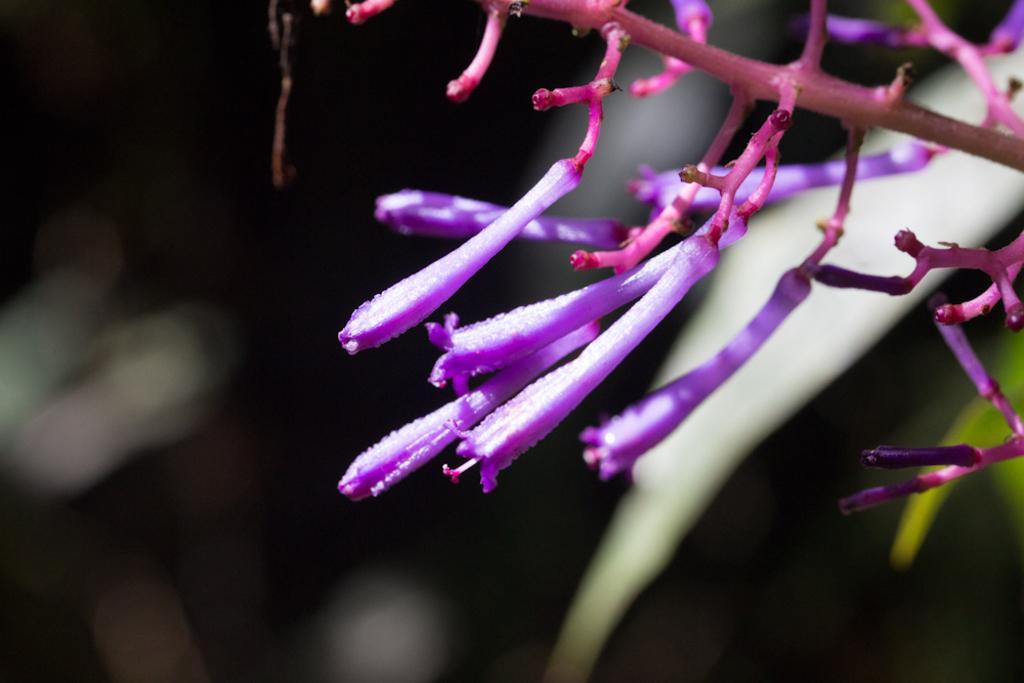What type of plant life is present in the image? There are flowers in the image. Where are the flowers located? The flowers are on a branch. What color are the flowers? The flowers are violet in color. What type of school can be seen in the image? There is no school present in the image; it features flowers on a branch. How many cows are visible in the image? There are no cows present in the image; it features flowers on a branch. 